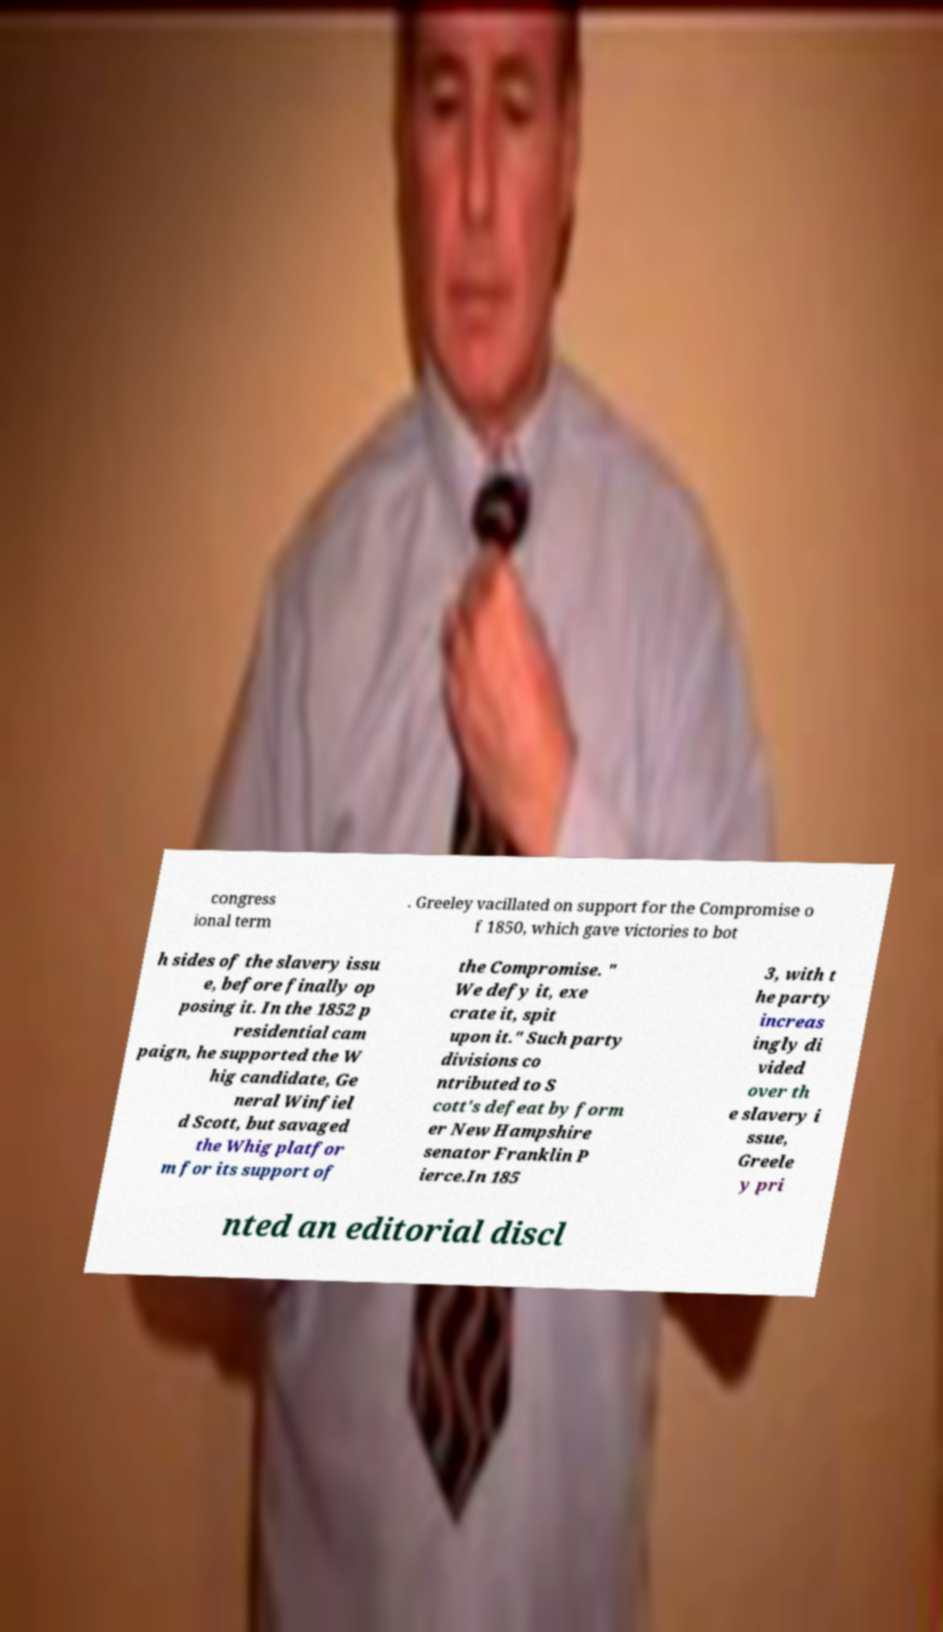Can you read and provide the text displayed in the image?This photo seems to have some interesting text. Can you extract and type it out for me? congress ional term . Greeley vacillated on support for the Compromise o f 1850, which gave victories to bot h sides of the slavery issu e, before finally op posing it. In the 1852 p residential cam paign, he supported the W hig candidate, Ge neral Winfiel d Scott, but savaged the Whig platfor m for its support of the Compromise. " We defy it, exe crate it, spit upon it." Such party divisions co ntributed to S cott's defeat by form er New Hampshire senator Franklin P ierce.In 185 3, with t he party increas ingly di vided over th e slavery i ssue, Greele y pri nted an editorial discl 